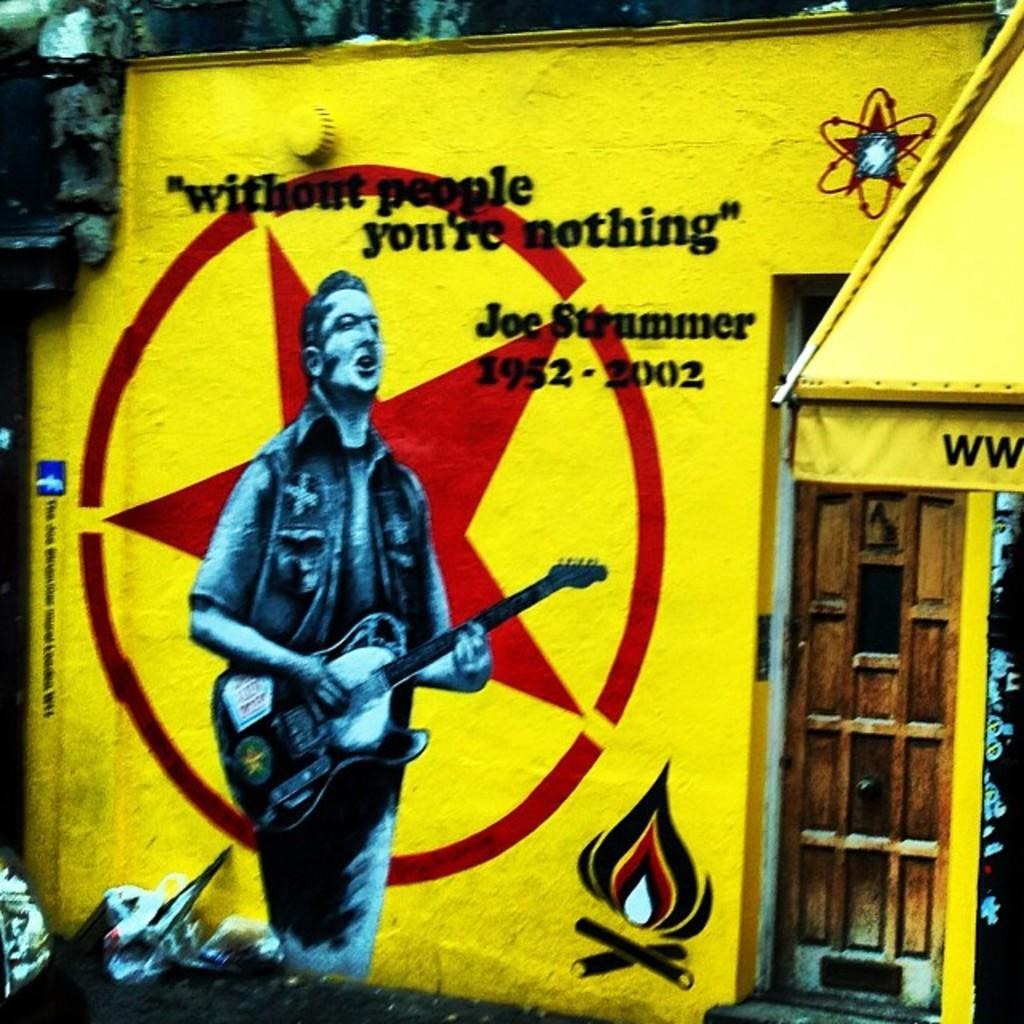Provide a one-sentence caption for the provided image. A building painted bright yellow has a picture of a man playing guitar and slogan "without people you. 